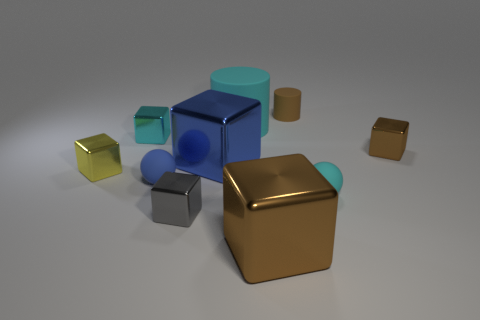There is a small rubber object that is the same color as the big matte object; what shape is it?
Your response must be concise. Sphere. How many brown objects have the same size as the cyan shiny block?
Your answer should be compact. 2. Are there any brown things that are right of the brown metal thing that is behind the yellow metal thing?
Your answer should be very brief. No. What number of things are either large purple metal balls or tiny yellow shiny things?
Offer a very short reply. 1. There is a cube that is on the right side of the tiny brown thing that is behind the tiny brown object right of the tiny matte cylinder; what is its color?
Offer a terse response. Brown. Is there anything else of the same color as the big matte object?
Ensure brevity in your answer.  Yes. Do the cyan shiny object and the brown rubber object have the same size?
Your answer should be very brief. Yes. How many objects are tiny metallic blocks in front of the cyan rubber ball or tiny objects on the left side of the brown matte thing?
Offer a terse response. 4. The tiny cyan thing that is on the left side of the large metallic block behind the small yellow metallic cube is made of what material?
Your response must be concise. Metal. What number of other things are made of the same material as the tiny blue ball?
Keep it short and to the point. 3. 